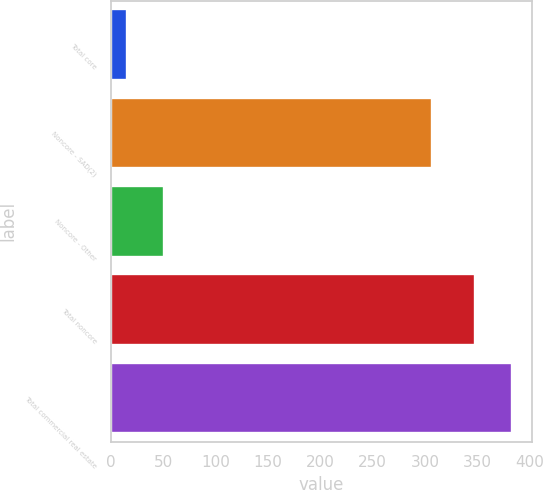<chart> <loc_0><loc_0><loc_500><loc_500><bar_chart><fcel>Total core<fcel>Noncore - SAD(2)<fcel>Noncore - Other<fcel>Total noncore<fcel>Total commercial real estate<nl><fcel>16<fcel>307<fcel>50.8<fcel>348<fcel>382.8<nl></chart> 